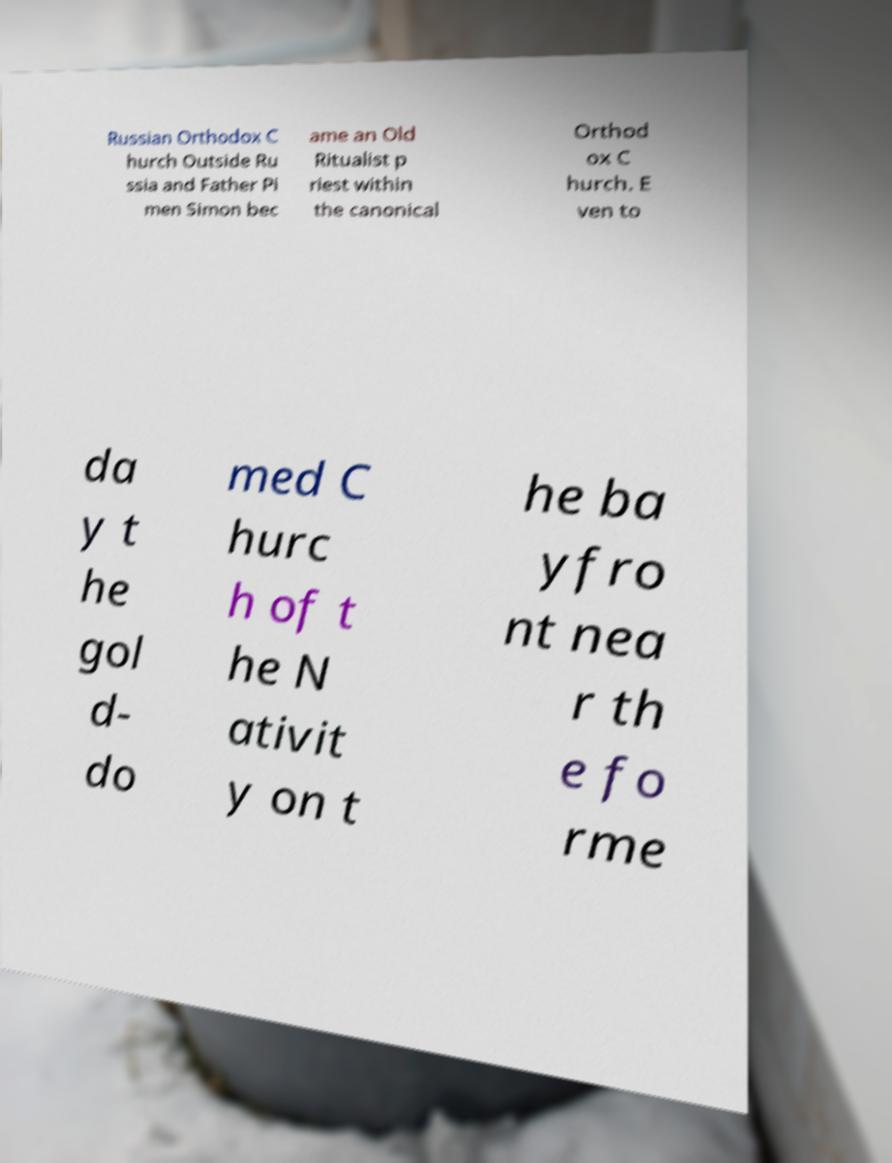Can you accurately transcribe the text from the provided image for me? Russian Orthodox C hurch Outside Ru ssia and Father Pi men Simon bec ame an Old Ritualist p riest within the canonical Orthod ox C hurch. E ven to da y t he gol d- do med C hurc h of t he N ativit y on t he ba yfro nt nea r th e fo rme 